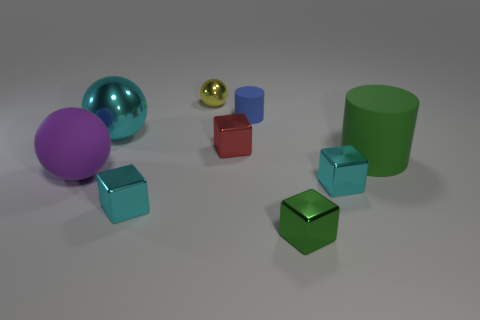Subtract all purple cubes. Subtract all blue cylinders. How many cubes are left? 4 Add 1 large metallic spheres. How many objects exist? 10 Subtract all cylinders. How many objects are left? 7 Subtract 0 blue cubes. How many objects are left? 9 Subtract all small green metallic cubes. Subtract all small green blocks. How many objects are left? 7 Add 6 big metallic objects. How many big metallic objects are left? 7 Add 6 small yellow shiny spheres. How many small yellow shiny spheres exist? 7 